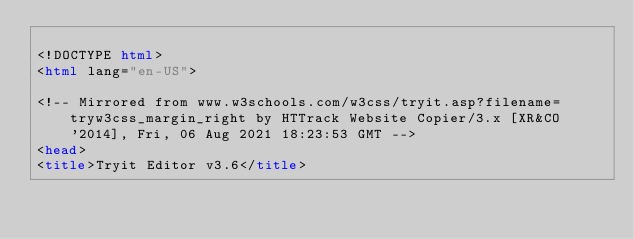Convert code to text. <code><loc_0><loc_0><loc_500><loc_500><_HTML_>
<!DOCTYPE html>
<html lang="en-US">

<!-- Mirrored from www.w3schools.com/w3css/tryit.asp?filename=tryw3css_margin_right by HTTrack Website Copier/3.x [XR&CO'2014], Fri, 06 Aug 2021 18:23:53 GMT -->
<head>
<title>Tryit Editor v3.6</title></code> 